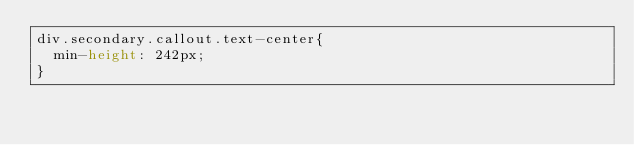Convert code to text. <code><loc_0><loc_0><loc_500><loc_500><_CSS_>div.secondary.callout.text-center{
  min-height: 242px;
}
</code> 